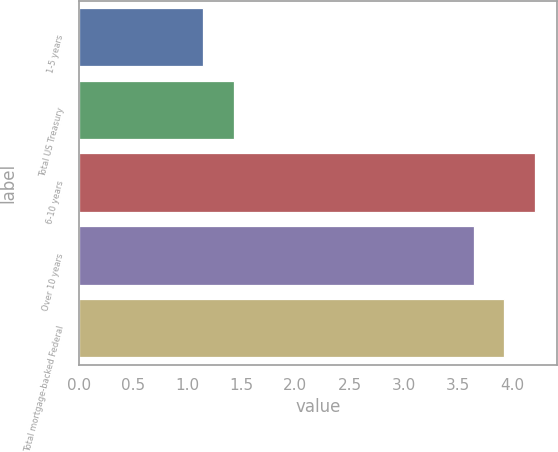<chart> <loc_0><loc_0><loc_500><loc_500><bar_chart><fcel>1-5 years<fcel>Total US Treasury<fcel>6-10 years<fcel>Over 10 years<fcel>Total mortgage-backed Federal<nl><fcel>1.15<fcel>1.43<fcel>4.21<fcel>3.65<fcel>3.93<nl></chart> 